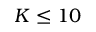Convert formula to latex. <formula><loc_0><loc_0><loc_500><loc_500>K \leq 1 0</formula> 